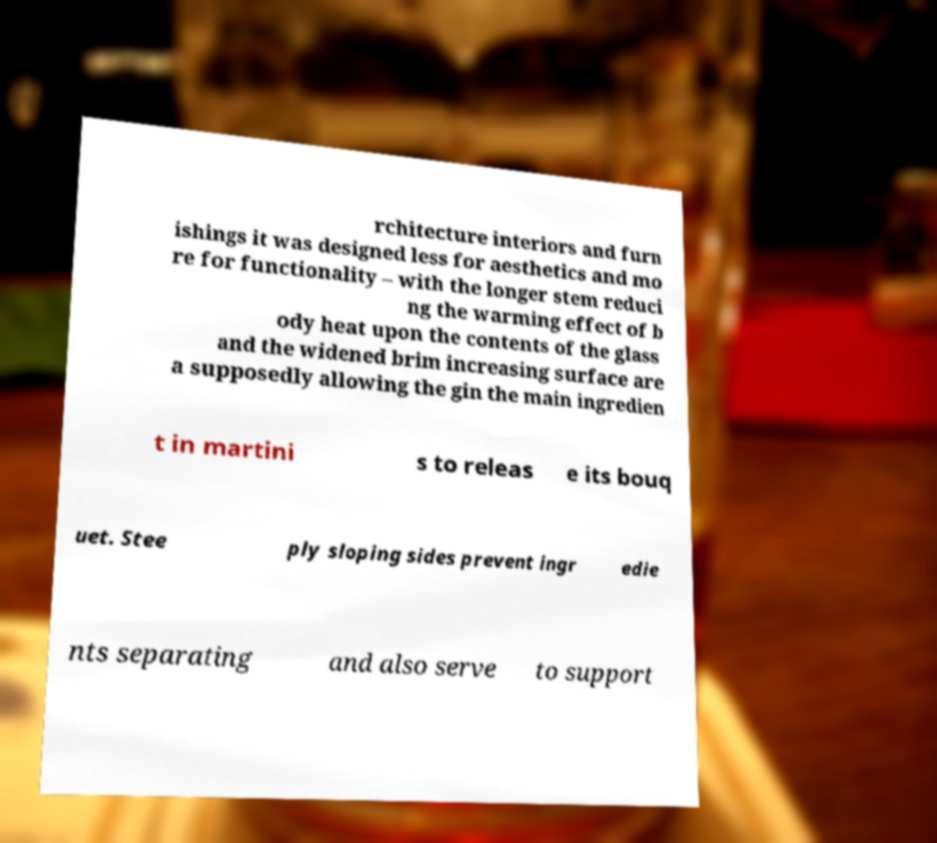I need the written content from this picture converted into text. Can you do that? rchitecture interiors and furn ishings it was designed less for aesthetics and mo re for functionality – with the longer stem reduci ng the warming effect of b ody heat upon the contents of the glass and the widened brim increasing surface are a supposedly allowing the gin the main ingredien t in martini s to releas e its bouq uet. Stee ply sloping sides prevent ingr edie nts separating and also serve to support 